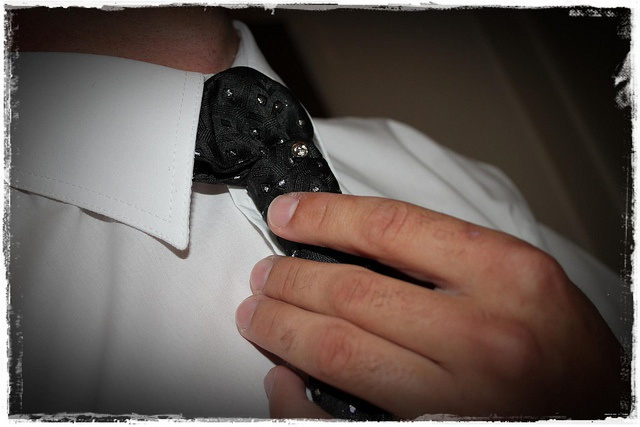Describe the objects in this image and their specific colors. I can see people in white, black, darkgray, gray, and brown tones and tie in white, black, gray, maroon, and darkgray tones in this image. 